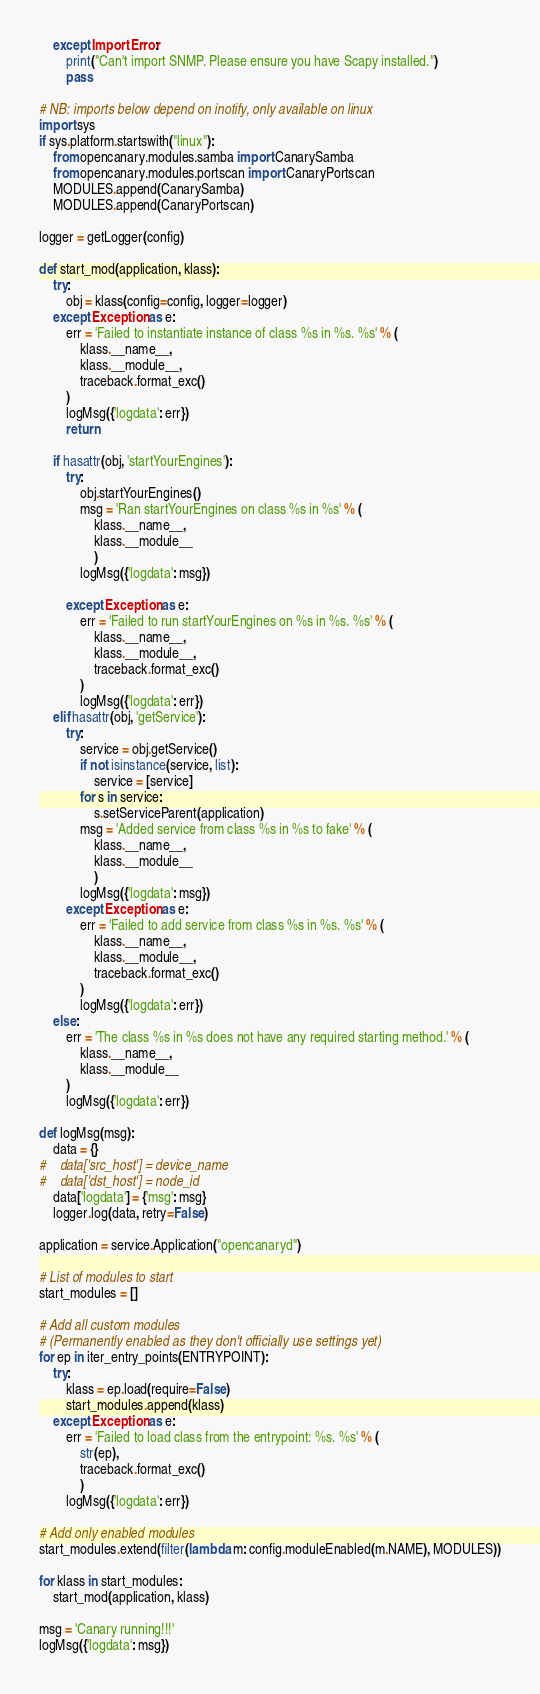<code> <loc_0><loc_0><loc_500><loc_500><_Python_>    except ImportError:
        print("Can't import SNMP. Please ensure you have Scapy installed.")
        pass

# NB: imports below depend on inotify, only available on linux
import sys
if sys.platform.startswith("linux"):
    from opencanary.modules.samba import CanarySamba
    from opencanary.modules.portscan import CanaryPortscan
    MODULES.append(CanarySamba)
    MODULES.append(CanaryPortscan)

logger = getLogger(config)

def start_mod(application, klass):
    try:
        obj = klass(config=config, logger=logger)
    except Exception as e:
        err = 'Failed to instantiate instance of class %s in %s. %s' % (
            klass.__name__,
            klass.__module__,
            traceback.format_exc()
        )
        logMsg({'logdata': err})
        return

    if hasattr(obj, 'startYourEngines'):
        try:
            obj.startYourEngines()
            msg = 'Ran startYourEngines on class %s in %s' % (
                klass.__name__,
                klass.__module__
                )
            logMsg({'logdata': msg})

        except Exception as e:
            err = 'Failed to run startYourEngines on %s in %s. %s' % (
                klass.__name__,
                klass.__module__,
                traceback.format_exc()
            )
            logMsg({'logdata': err})
    elif hasattr(obj, 'getService'):
        try:
            service = obj.getService()
            if not isinstance(service, list):
                service = [service]
            for s in service:
                s.setServiceParent(application)
            msg = 'Added service from class %s in %s to fake' % (
                klass.__name__,
                klass.__module__
                )
            logMsg({'logdata': msg})
        except Exception as e:
            err = 'Failed to add service from class %s in %s. %s' % (
                klass.__name__,
                klass.__module__,
                traceback.format_exc()
            )
            logMsg({'logdata': err})
    else:
        err = 'The class %s in %s does not have any required starting method.' % (
            klass.__name__,
            klass.__module__
        )
        logMsg({'logdata': err})

def logMsg(msg):
    data = {}
#    data['src_host'] = device_name
#    data['dst_host'] = node_id
    data['logdata'] = {'msg': msg}
    logger.log(data, retry=False)

application = service.Application("opencanaryd")

# List of modules to start
start_modules = []

# Add all custom modules
# (Permanently enabled as they don't officially use settings yet)
for ep in iter_entry_points(ENTRYPOINT):
    try:
        klass = ep.load(require=False)
        start_modules.append(klass)
    except Exception as e:
        err = 'Failed to load class from the entrypoint: %s. %s' % (
            str(ep),
            traceback.format_exc()
            )
        logMsg({'logdata': err})

# Add only enabled modules
start_modules.extend(filter(lambda m: config.moduleEnabled(m.NAME), MODULES))

for klass in start_modules:
    start_mod(application, klass)

msg = 'Canary running!!!'
logMsg({'logdata': msg})
</code> 